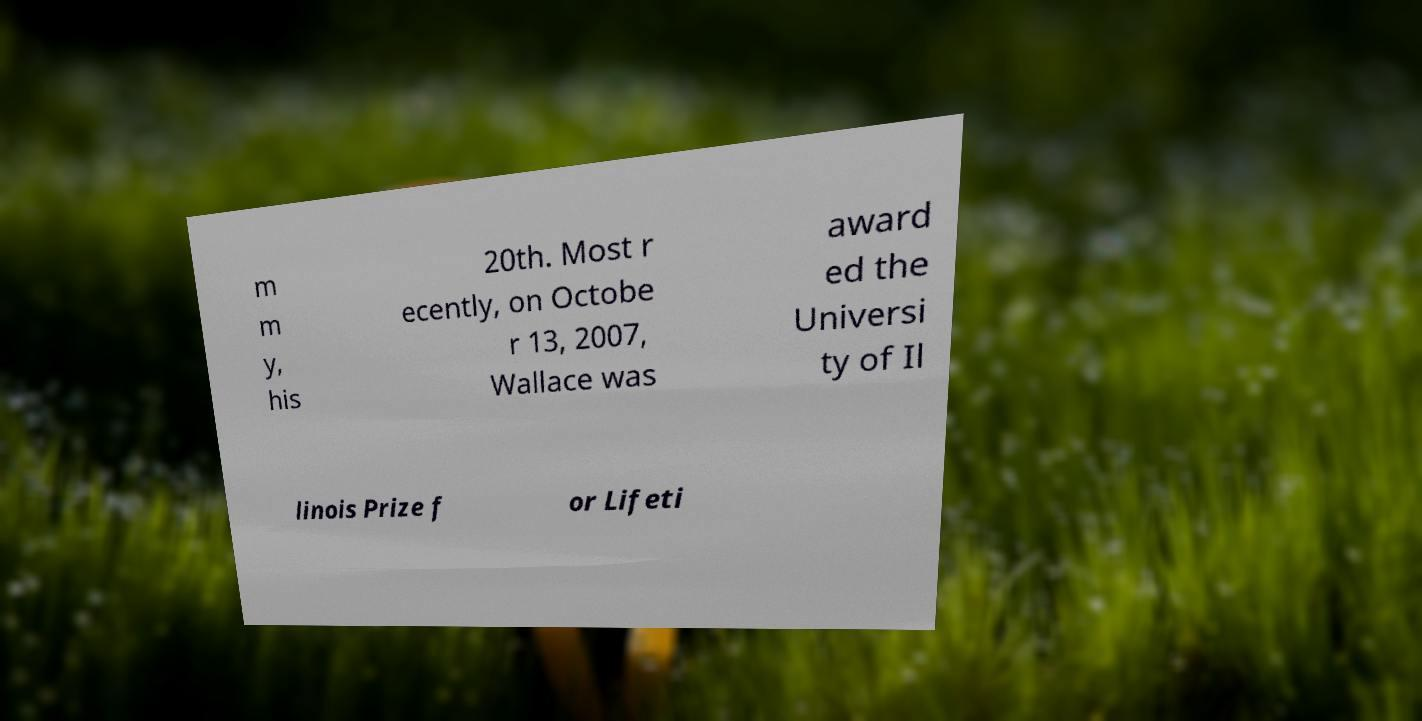There's text embedded in this image that I need extracted. Can you transcribe it verbatim? m m y, his 20th. Most r ecently, on Octobe r 13, 2007, Wallace was award ed the Universi ty of Il linois Prize f or Lifeti 